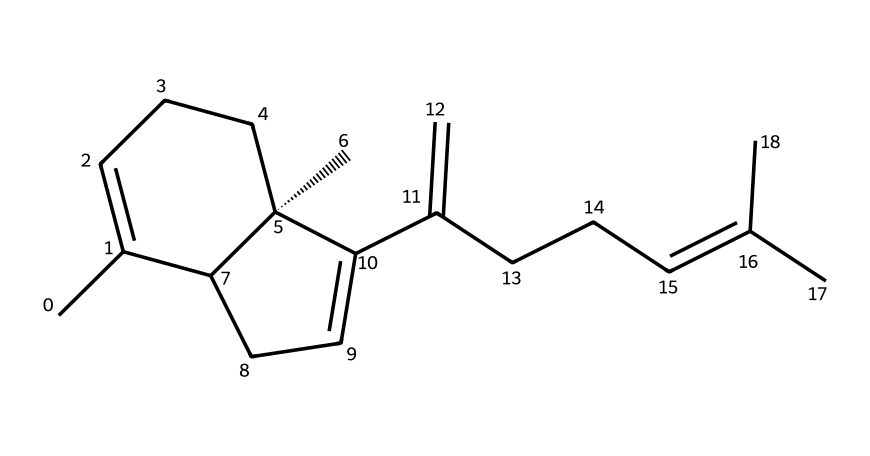How many carbon atoms are in beta-caryophyllene? To find the number of carbon atoms, you can count the 'C' symbols in the SMILES representation. Each 'C' represents a carbon atom in the structure. In this case, there are 15 occurrences of 'C'.
Answer: 15 What is the total number of double bonds in the structure? To determine the number of double bonds, look for '=' signs in the SMILES representation. Each '=' sign indicates a double bond. In this structure, there are 3 instances of '=' representing double bonds.
Answer: 3 What type of chemical compound is beta-caryophyllene? Beta-caryophyllene is classified as a terpene, which is identified by its specific molecular structure featuring a combination of carbon atoms connected in a cyclic arrangement.
Answer: terpene Is beta-caryophyllene a cyclic compound? Yes, the structure has rings formed by carbon atoms, indicating it is cyclic. The presence of cycloalkane features within the structure supports this classification.
Answer: yes Which functional groups, if any, are present in beta-caryophyllene? In observing the structure, beta-caryophyllene primarily consists of hydrocarbons with no functional groups like -OH or -COOH; it is mainly made up of carbon (C) and hydrogen (H) atoms.
Answer: none What is the stereochemistry configuration of beta-caryophyllene based on the SMILES? The '@' symbol indicates the presence of chiral centers in beta-caryophyllene. Specifically, the carbon with the '@' shows a specific stereochemistry as it has multiple substituents indicating chirality.
Answer: chiral 